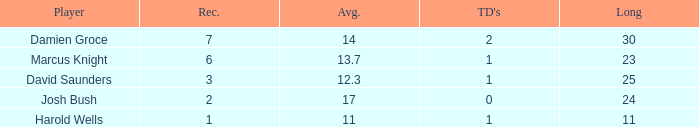How many touchdowns have a length shorter than 23 yards? 1.0. 